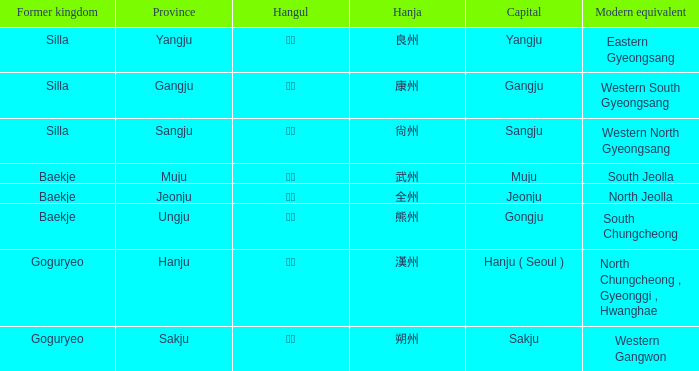What is the hangul symbol for the hanja 良州? 양주. Parse the full table. {'header': ['Former kingdom', 'Province', 'Hangul', 'Hanja', 'Capital', 'Modern equivalent'], 'rows': [['Silla', 'Yangju', '양주', '良州', 'Yangju', 'Eastern Gyeongsang'], ['Silla', 'Gangju', '강주', '康州', 'Gangju', 'Western South Gyeongsang'], ['Silla', 'Sangju', '상주', '尙州', 'Sangju', 'Western North Gyeongsang'], ['Baekje', 'Muju', '무주', '武州', 'Muju', 'South Jeolla'], ['Baekje', 'Jeonju', '전주', '全州', 'Jeonju', 'North Jeolla'], ['Baekje', 'Ungju', '웅주', '熊州', 'Gongju', 'South Chungcheong'], ['Goguryeo', 'Hanju', '한주', '漢州', 'Hanju ( Seoul )', 'North Chungcheong , Gyeonggi , Hwanghae'], ['Goguryeo', 'Sakju', '삭주', '朔州', 'Sakju', 'Western Gangwon']]} 